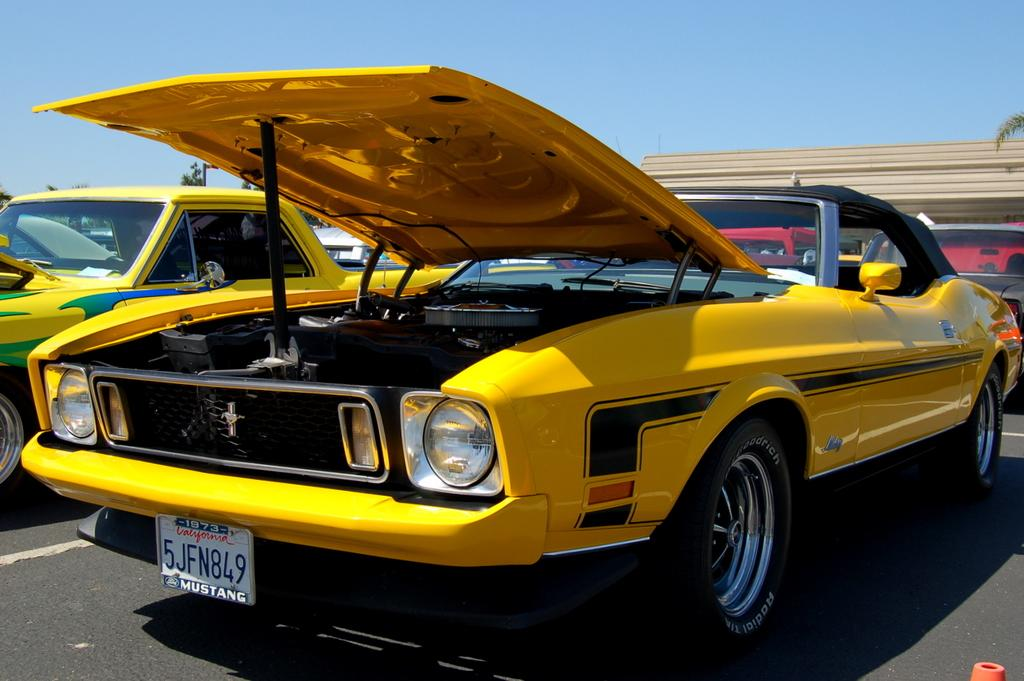Provide a one-sentence caption for the provided image. The yellow convertible is on display somewhere in California. 